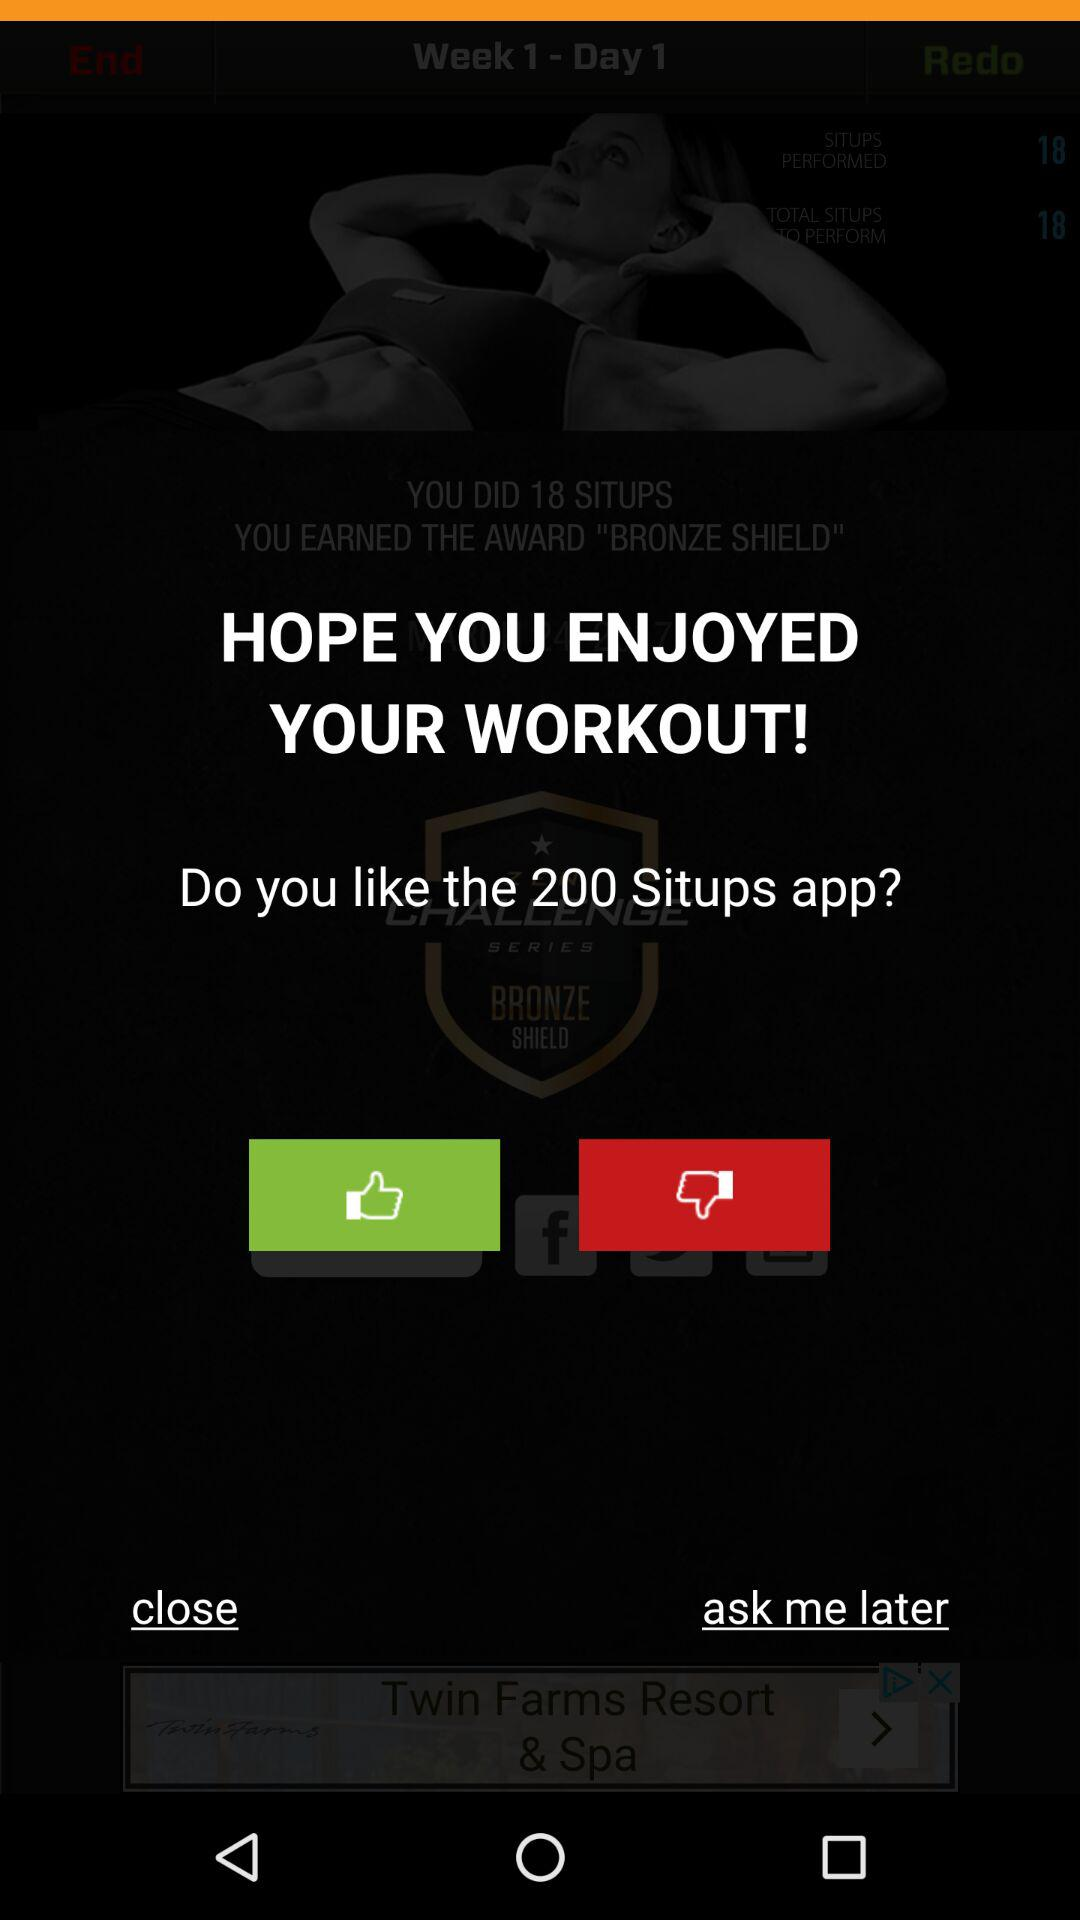How many situps have been performed? Situps that have been performed are 330. 